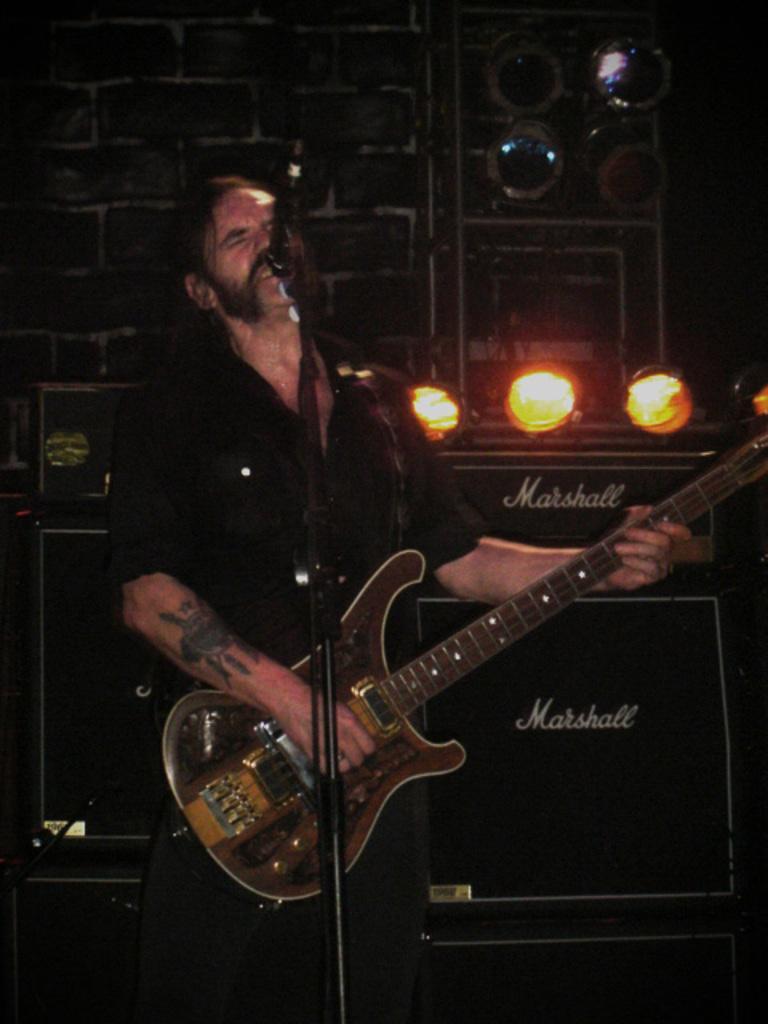Describe this image in one or two sentences. In this picture we can see a man standing in front of mike, and he is playing guitar. On the background we can see the wall. And these are the lights. 